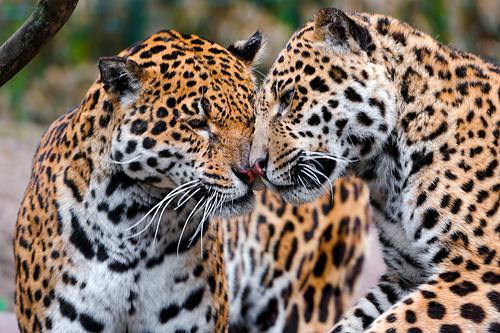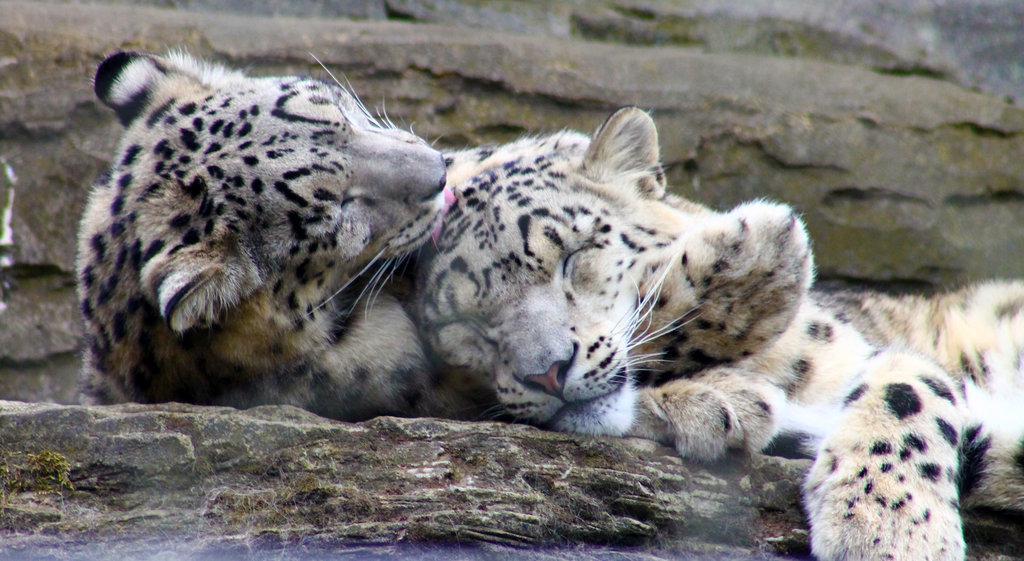The first image is the image on the left, the second image is the image on the right. For the images shown, is this caption "The left image shows two spotted wildcats face to face, with heads level, and the right image shows exactly one spotted wildcat licking the other." true? Answer yes or no. Yes. 